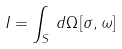<formula> <loc_0><loc_0><loc_500><loc_500>I = \int _ { S } \, d \Omega \, [ \sigma , \omega ]</formula> 